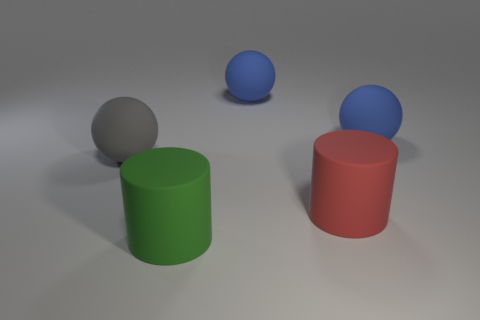Subtract all cylinders. How many objects are left? 3 Subtract 0 red balls. How many objects are left? 5 Subtract 2 spheres. How many spheres are left? 1 Subtract all gray balls. Subtract all yellow blocks. How many balls are left? 2 Subtract all purple cylinders. How many red spheres are left? 0 Subtract all large blue objects. Subtract all big blue rubber balls. How many objects are left? 1 Add 4 large green objects. How many large green objects are left? 5 Add 5 tiny cyan metallic cubes. How many tiny cyan metallic cubes exist? 5 Add 5 red objects. How many objects exist? 10 Subtract all red cylinders. How many cylinders are left? 1 